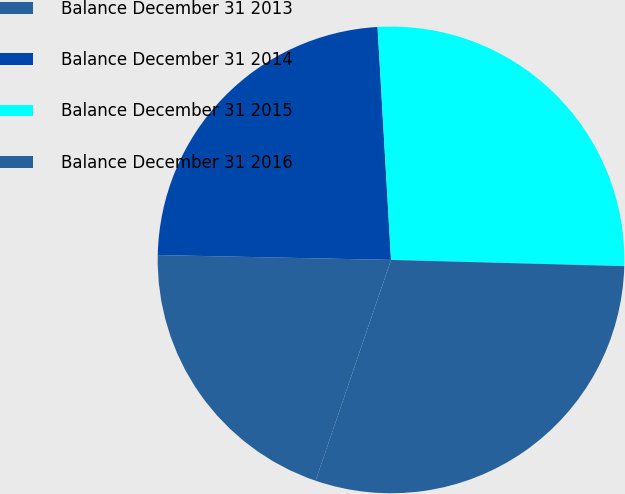Convert chart to OTSL. <chart><loc_0><loc_0><loc_500><loc_500><pie_chart><fcel>Balance December 31 2013<fcel>Balance December 31 2014<fcel>Balance December 31 2015<fcel>Balance December 31 2016<nl><fcel>20.09%<fcel>23.75%<fcel>26.34%<fcel>29.82%<nl></chart> 